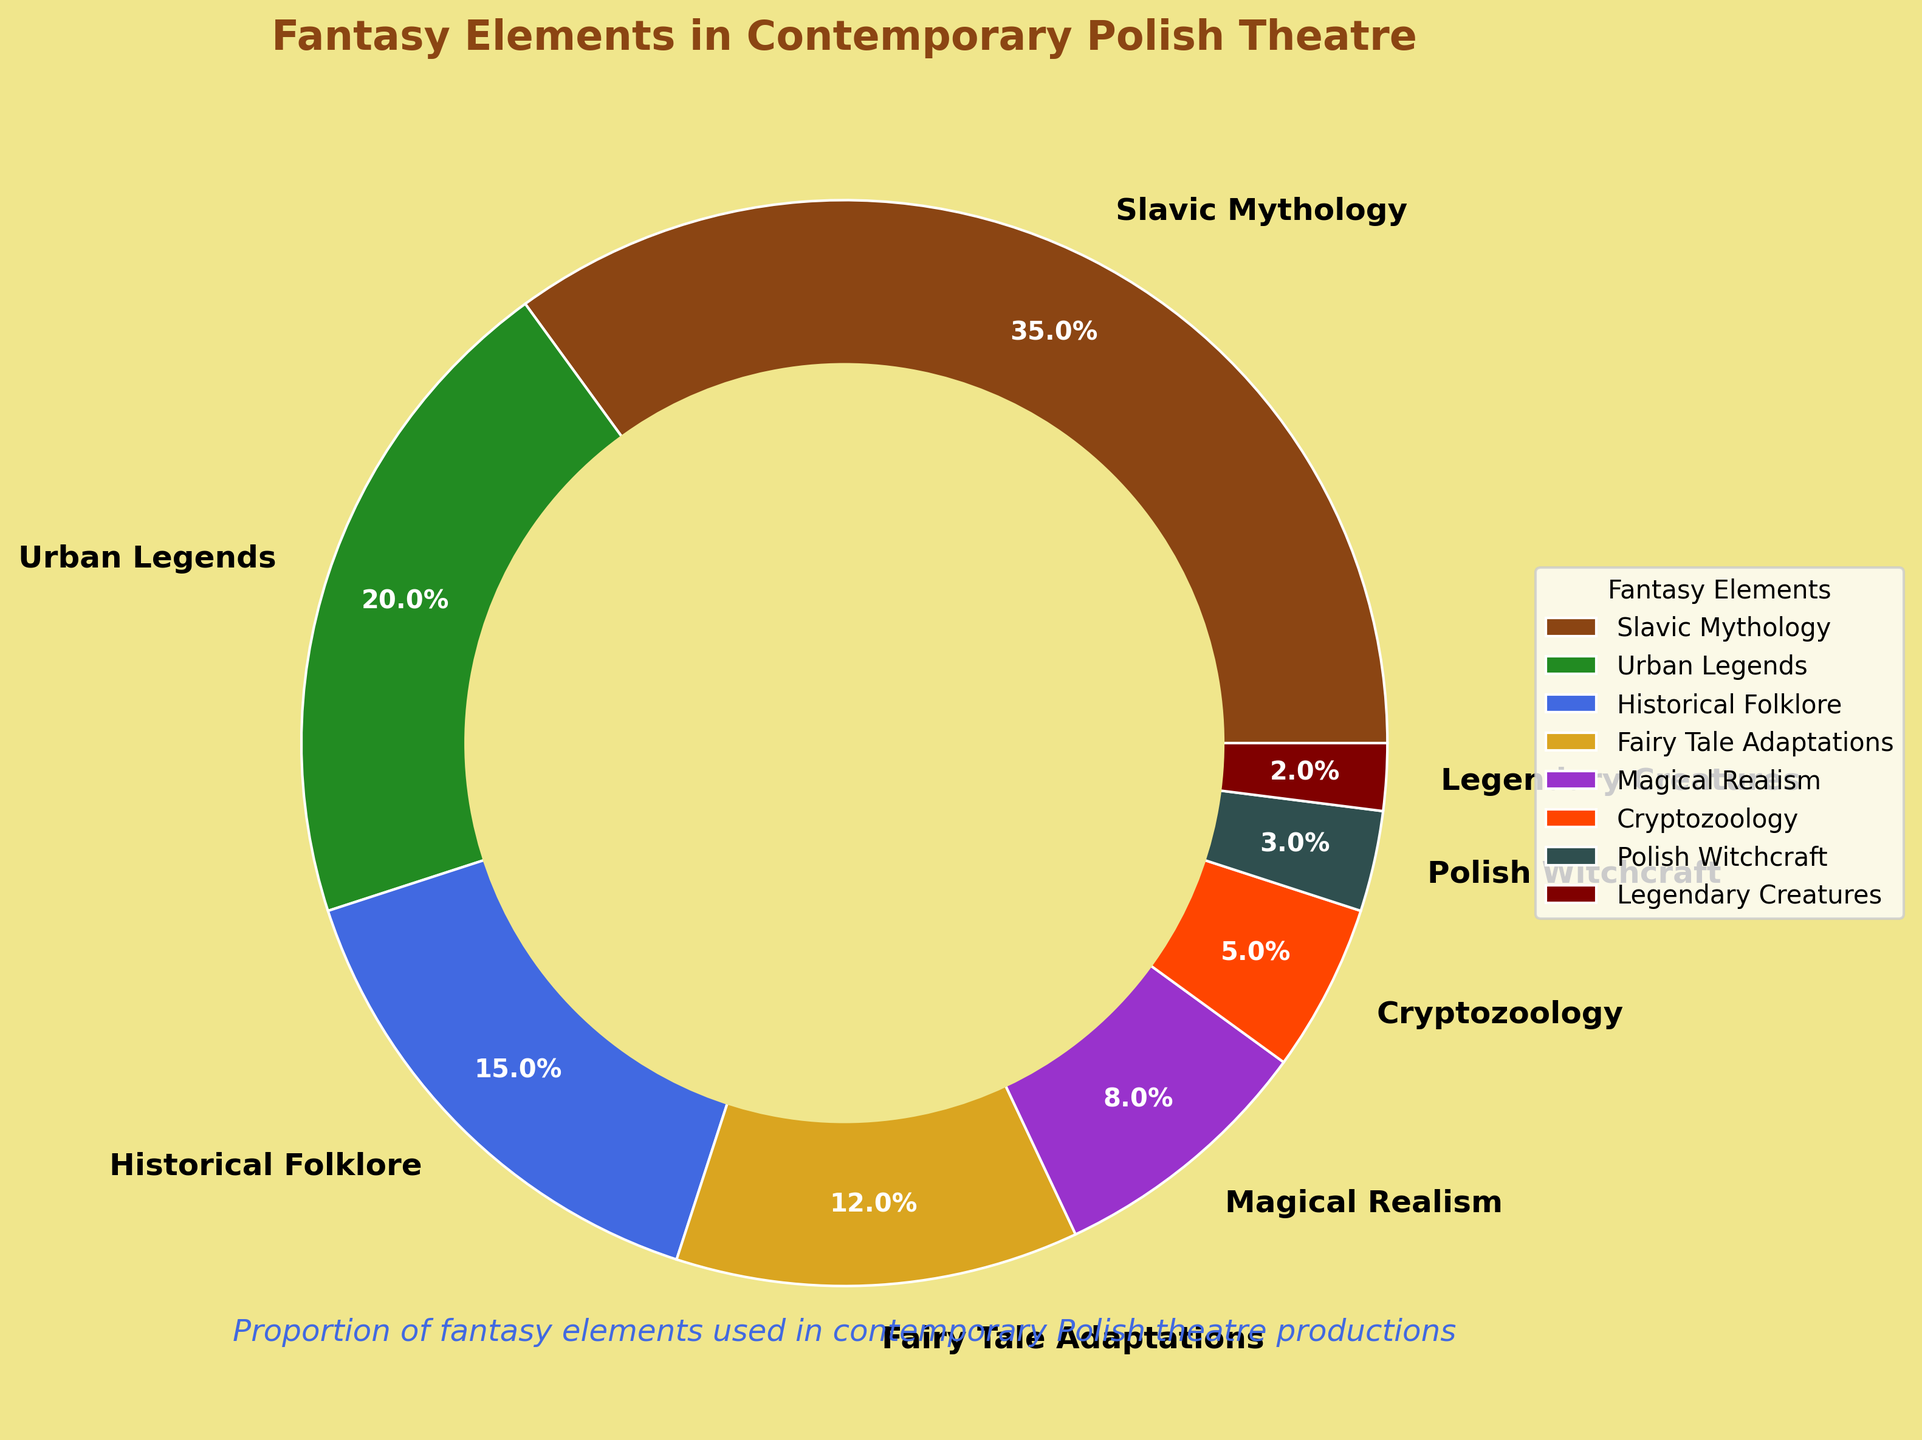Which fantasy element has the highest proportion? Slavic Mythology has the largest portion visually indicated by the largest segment in the pie chart.
Answer: Slavic Mythology What is the combined proportion of Urban Legends and Historical Folklore? The proportion of Urban Legends is 20% and Historical Folklore is 15%. Summing these gives 20% + 15% = 35%.
Answer: 35% Which fantasy element has the smallest proportion? Based on the smallest segment in the pie chart, Legendary Creatures has the smallest portion.
Answer: Legendary Creatures How many more percentage points does Slavic Mythology have compared to Magical Realism? Slavic Mythology has 35% and Magical Realism has 8%. The difference is 35% - 8% = 27%.
Answer: 27% Does the combination of Fairy Tale Adaptations and Magical Realism exceed the proportion of Urban Legends? Fairy Tale Adaptations are 12% and Magical Realism is 8%. Together they sum to 12% + 8% = 20%, which is equal to the proportion of Urban Legends at 20%.
Answer: No Between Slavic Mythology and Urban Legends, which has a lower proportion? By directly comparing the sizes of the segments, Urban Legends with 20% has a lower proportion than Slavic Mythology with 35%.
Answer: Urban Legends What is the total proportion represented by the three smallest fantasy elements? The proportions are Polish Witchcraft (3%), Legendary Creatures (2%), and Cryptozoology (5%). Summing these gives 3% + 2% + 5% = 10%.
Answer: 10% Which fantasy element uses a green color in the pie chart? Based on the color scheme described, Urban Legends uses the green color.
Answer: Urban Legends Can the sum of proportions of Historical Folklore and Cryptozoology exceed the proportion of Slavic Mythology? Historical Folklore is 15% and Cryptozoology is 5%. Their sum is 15% + 5% = 20%, which is less than the 35% for Slavic Mythology.
Answer: No 